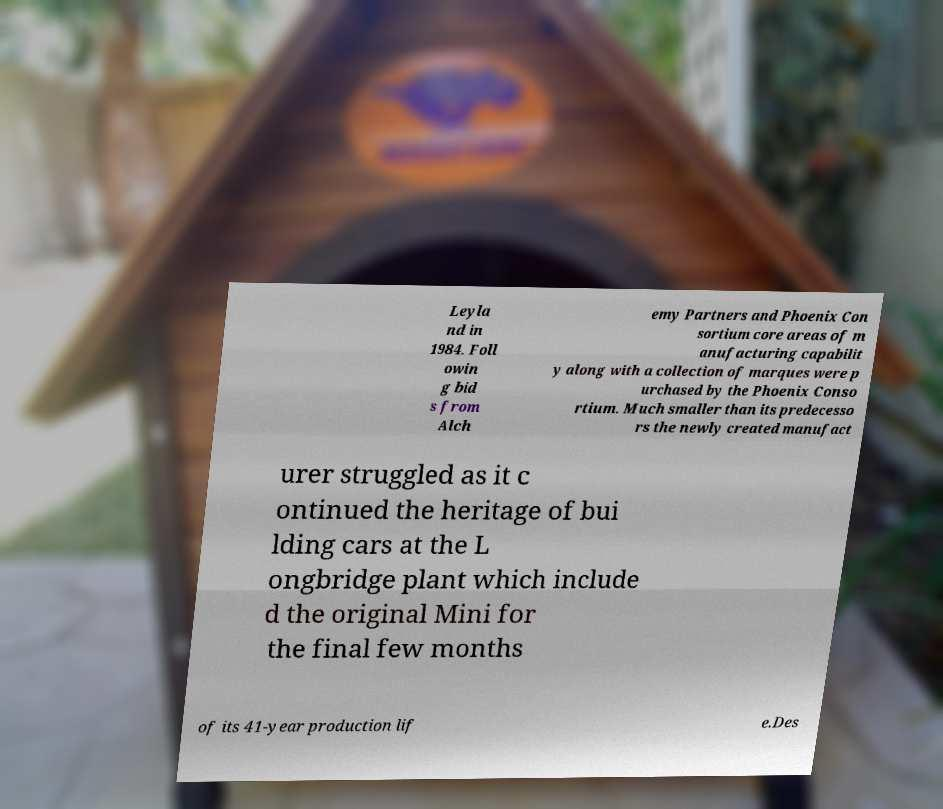Can you read and provide the text displayed in the image?This photo seems to have some interesting text. Can you extract and type it out for me? Leyla nd in 1984. Foll owin g bid s from Alch emy Partners and Phoenix Con sortium core areas of m anufacturing capabilit y along with a collection of marques were p urchased by the Phoenix Conso rtium. Much smaller than its predecesso rs the newly created manufact urer struggled as it c ontinued the heritage of bui lding cars at the L ongbridge plant which include d the original Mini for the final few months of its 41-year production lif e.Des 